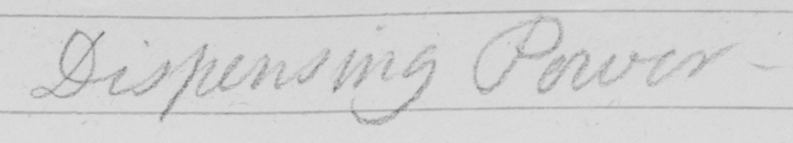Please provide the text content of this handwritten line. Dispensing Power 